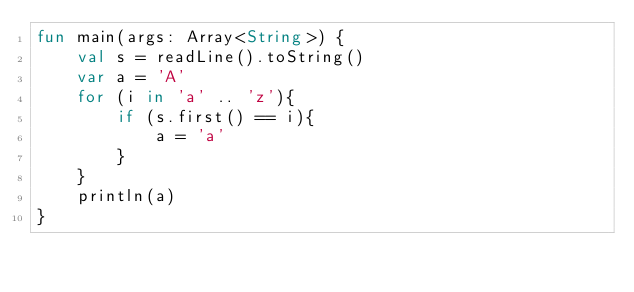Convert code to text. <code><loc_0><loc_0><loc_500><loc_500><_Kotlin_>fun main(args: Array<String>) {
    val s = readLine().toString()
    var a = 'A'
    for (i in 'a' .. 'z'){
        if (s.first() == i){
            a = 'a'
        }
    }
    println(a)
}
</code> 